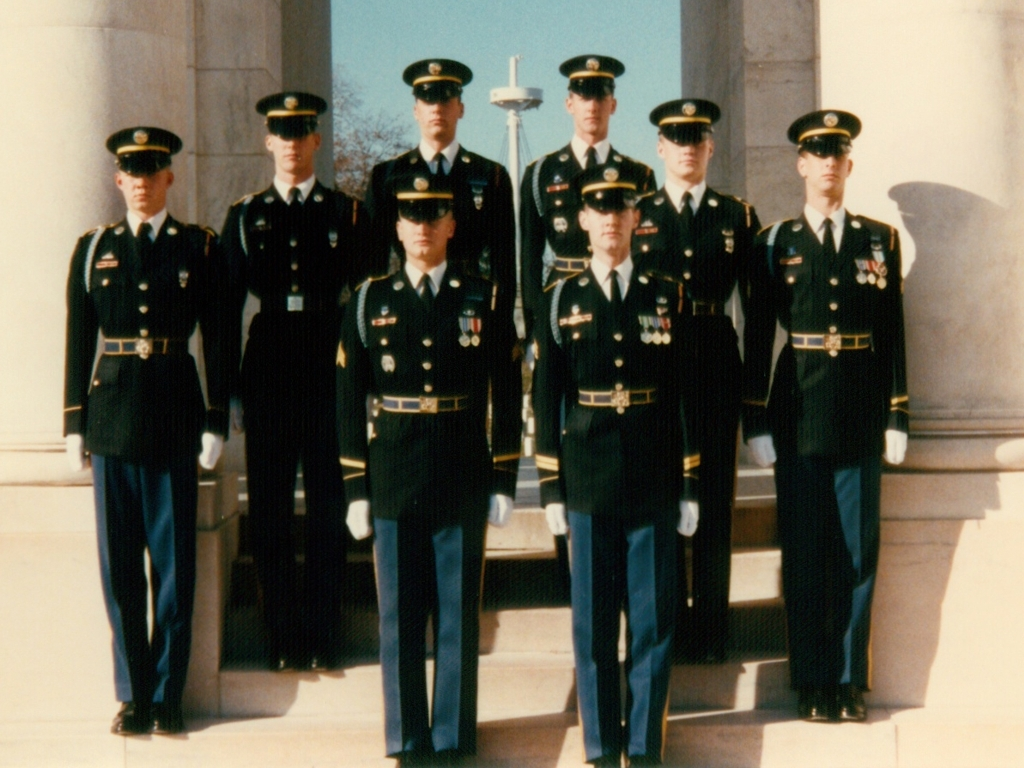What time of day do you think this photo was taken? Considering the shadows are short and directly beneath the individuals, it suggests that this photo was taken around midday, when the sun is high in the sky. Does the lighting affect the quality of this photo in any way? The midday lighting ensures that the subjects are well-lit and easily visible. However, the harshness of direct sunlight can sometimes introduce contrast issues and wash out some details. 